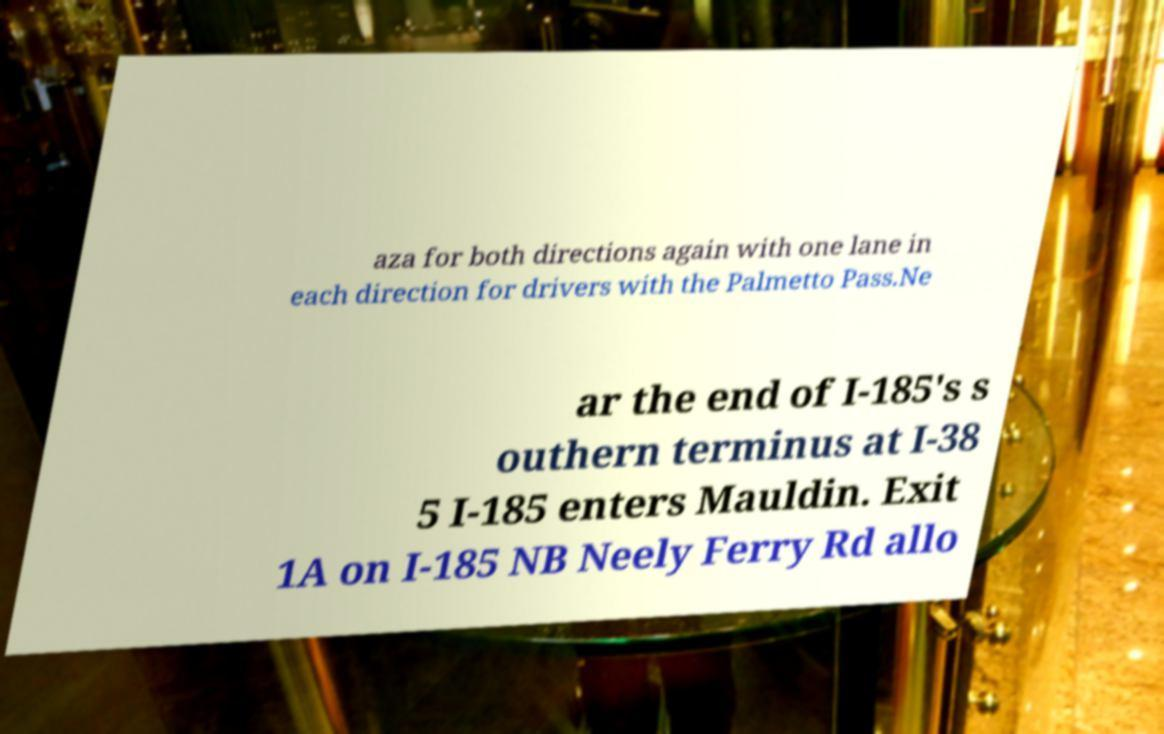What messages or text are displayed in this image? I need them in a readable, typed format. aza for both directions again with one lane in each direction for drivers with the Palmetto Pass.Ne ar the end of I-185's s outhern terminus at I-38 5 I-185 enters Mauldin. Exit 1A on I-185 NB Neely Ferry Rd allo 